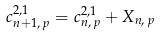Convert formula to latex. <formula><loc_0><loc_0><loc_500><loc_500>c ^ { 2 , 1 } _ { n + 1 , \, p } = c ^ { 2 , 1 } _ { n , \, p } + X _ { n , \, p }</formula> 